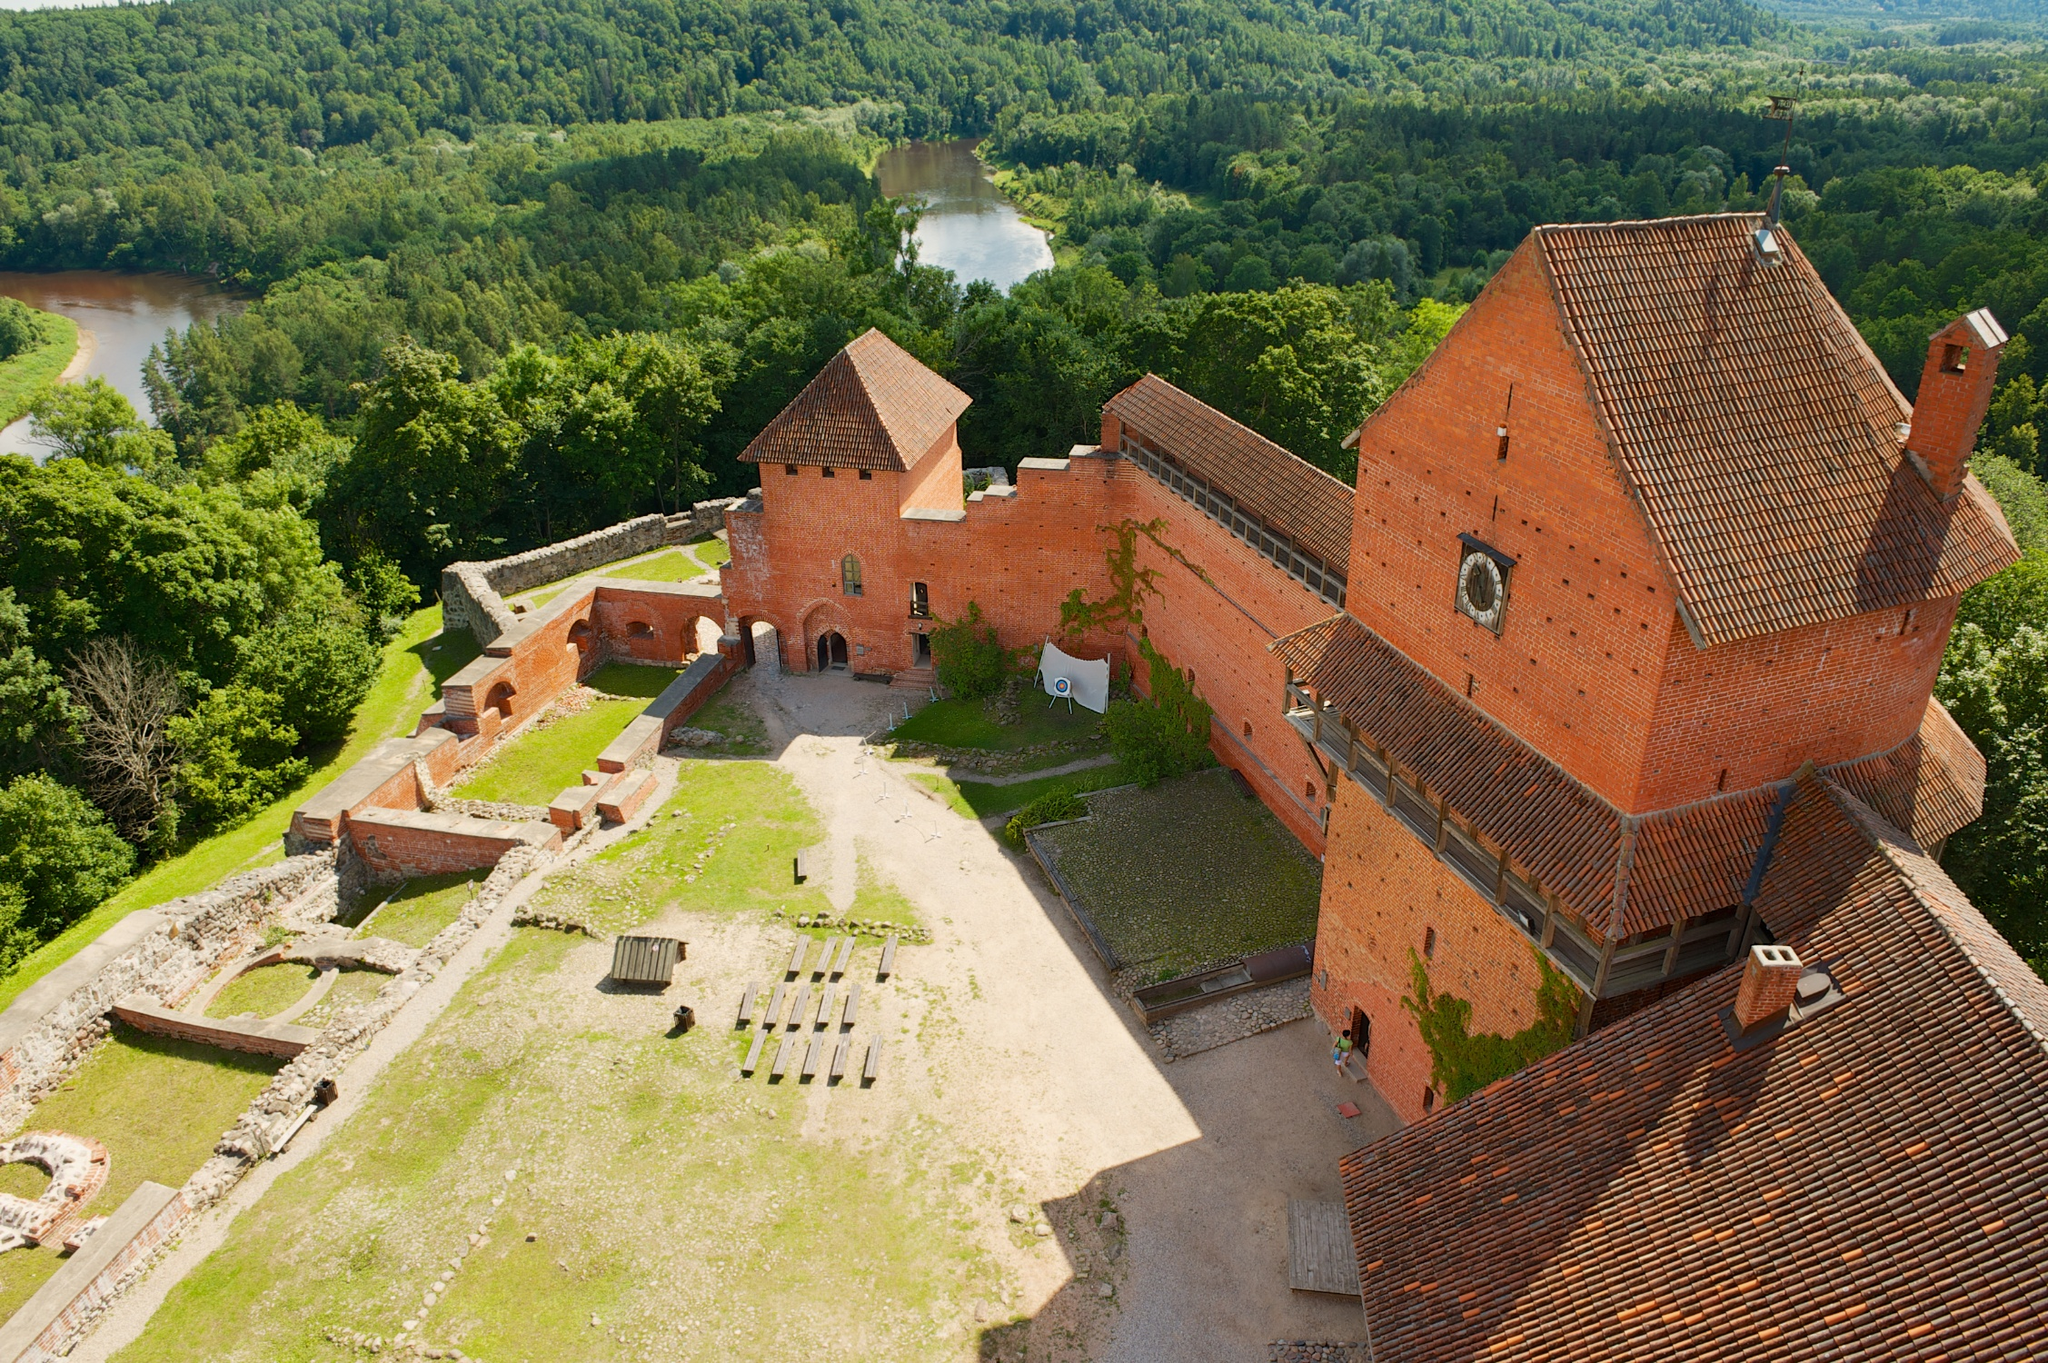If this castle could tell a story, what would it be? Once upon a time, this castle stood as a beacon of strength and power. It was home to a courageous knight named Sir Alden, who was renowned for his bravery and wisdom. Sir Alden’s tale began when he defended the castle from invaders who sought to conquer the lands. Leading his small band of loyal warriors, Sir Alden devised clever strategies to outmaneuver the enemy. His valor became legendary, and the castle thrived under his protection. As years passed, the castle saw peaceful times and served as a place of learning and culture. An academy was established within its walls, where scholars and artisans gathered. Sir Alden's descendants continued to uphold the castle's legacy, ensuring it remained a center of knowledge and strength. The castle walls, if they could speak, would recount the tales of bravery, wisdom, and a harmonious blend of defense and enlightenment. 